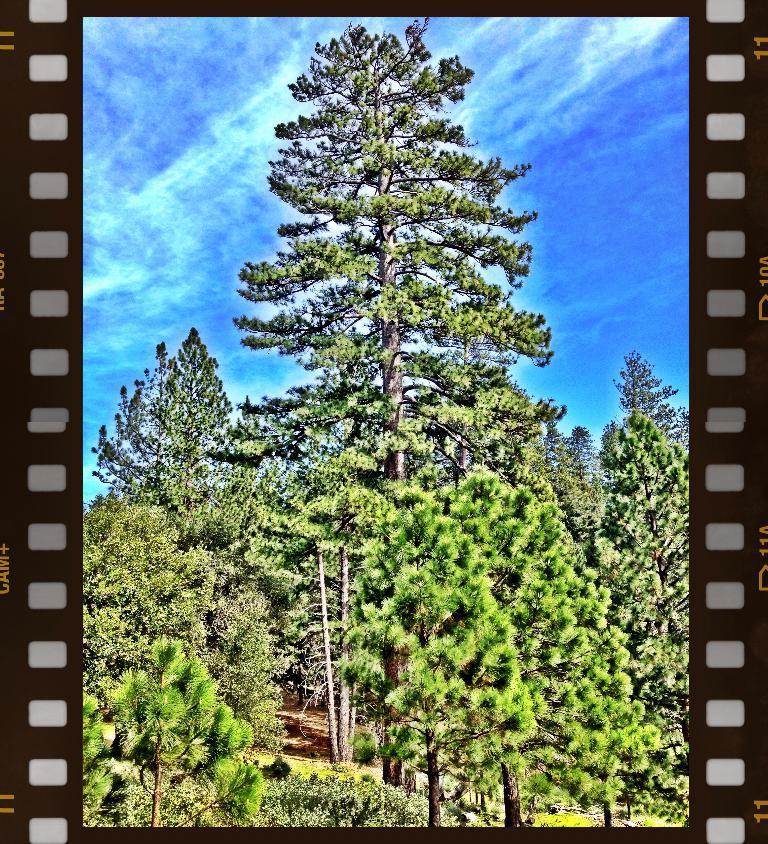In one or two sentences, can you explain what this image depicts? In this image I can see many trees and in the background I can see blue sky. 